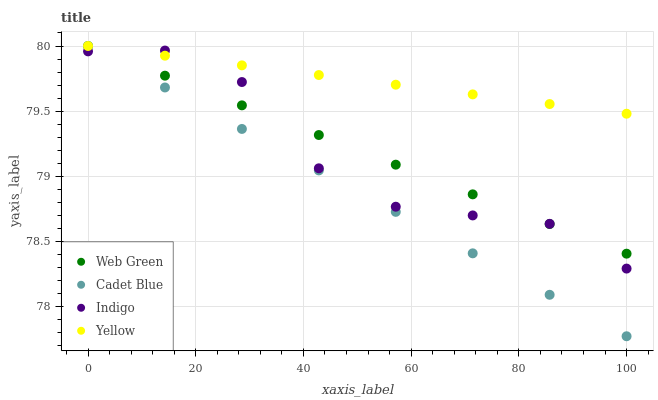Does Cadet Blue have the minimum area under the curve?
Answer yes or no. Yes. Does Yellow have the maximum area under the curve?
Answer yes or no. Yes. Does Indigo have the minimum area under the curve?
Answer yes or no. No. Does Indigo have the maximum area under the curve?
Answer yes or no. No. Is Web Green the smoothest?
Answer yes or no. Yes. Is Indigo the roughest?
Answer yes or no. Yes. Is Yellow the smoothest?
Answer yes or no. No. Is Yellow the roughest?
Answer yes or no. No. Does Cadet Blue have the lowest value?
Answer yes or no. Yes. Does Indigo have the lowest value?
Answer yes or no. No. Does Web Green have the highest value?
Answer yes or no. Yes. Does Indigo have the highest value?
Answer yes or no. No. Does Indigo intersect Cadet Blue?
Answer yes or no. Yes. Is Indigo less than Cadet Blue?
Answer yes or no. No. Is Indigo greater than Cadet Blue?
Answer yes or no. No. 